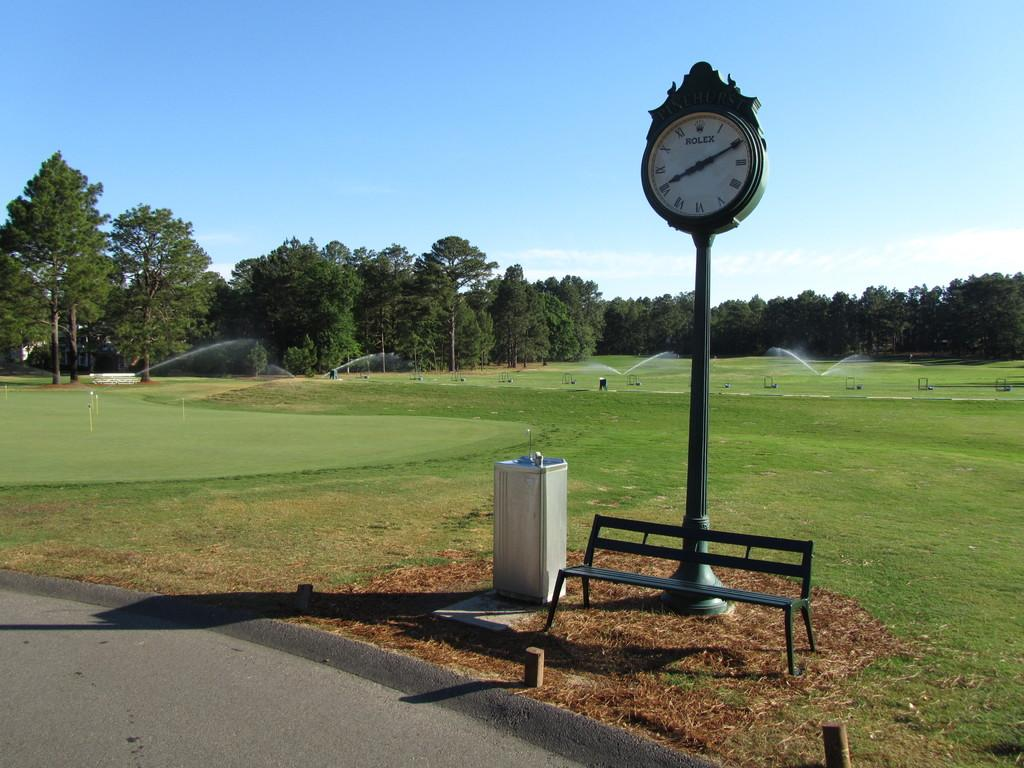<image>
Relay a brief, clear account of the picture shown. An empty park features a tall clock that says Rolex on it. 